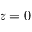Convert formula to latex. <formula><loc_0><loc_0><loc_500><loc_500>z = 0</formula> 